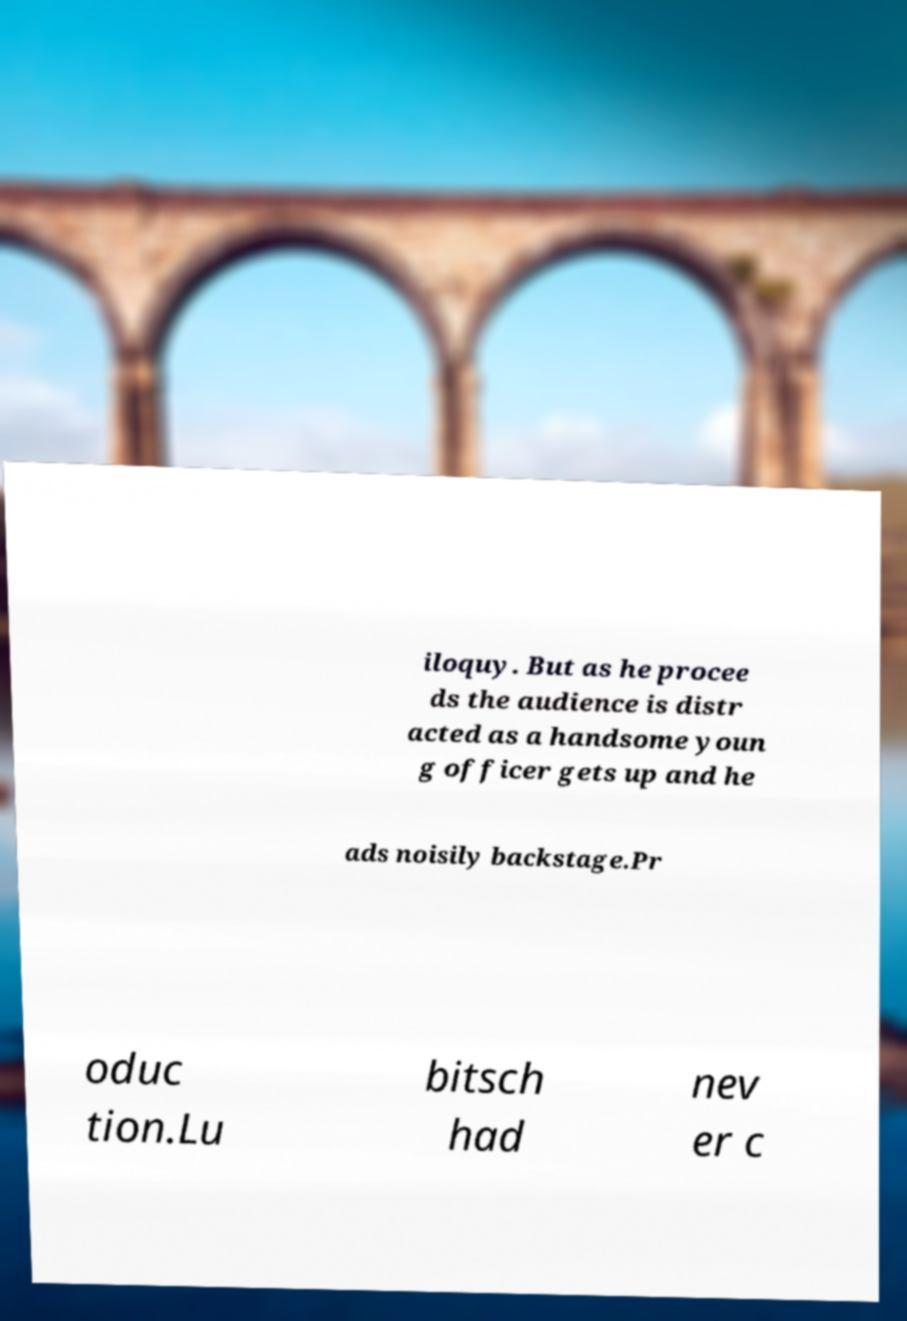Can you read and provide the text displayed in the image?This photo seems to have some interesting text. Can you extract and type it out for me? iloquy. But as he procee ds the audience is distr acted as a handsome youn g officer gets up and he ads noisily backstage.Pr oduc tion.Lu bitsch had nev er c 